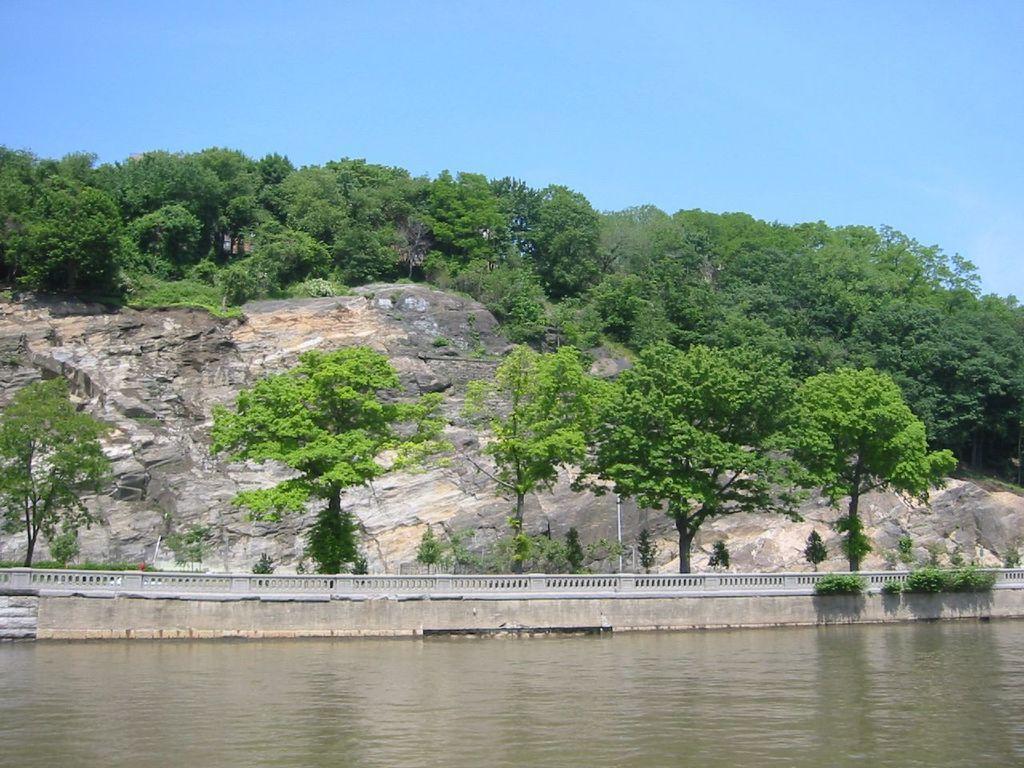In one or two sentences, can you explain what this image depicts? In this image, we can see so many trees, plants, pole, rocks, railing. At the bottom, we can see the water. Top of the image, we can see the sky. 